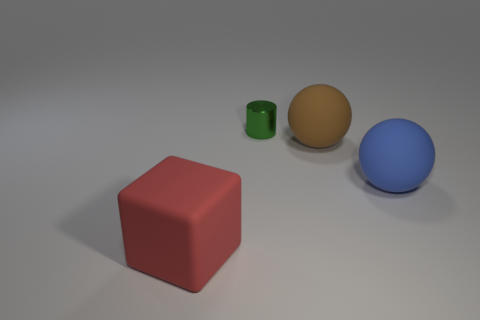Subtract all brown balls. How many balls are left? 1 Subtract 0 red spheres. How many objects are left? 4 Subtract all cylinders. How many objects are left? 3 Subtract 1 balls. How many balls are left? 1 Subtract all purple balls. Subtract all purple cylinders. How many balls are left? 2 Subtract all yellow balls. How many gray cylinders are left? 0 Subtract all brown matte cylinders. Subtract all large blue balls. How many objects are left? 3 Add 1 green metal objects. How many green metal objects are left? 2 Add 1 large blocks. How many large blocks exist? 2 Add 2 brown things. How many objects exist? 6 